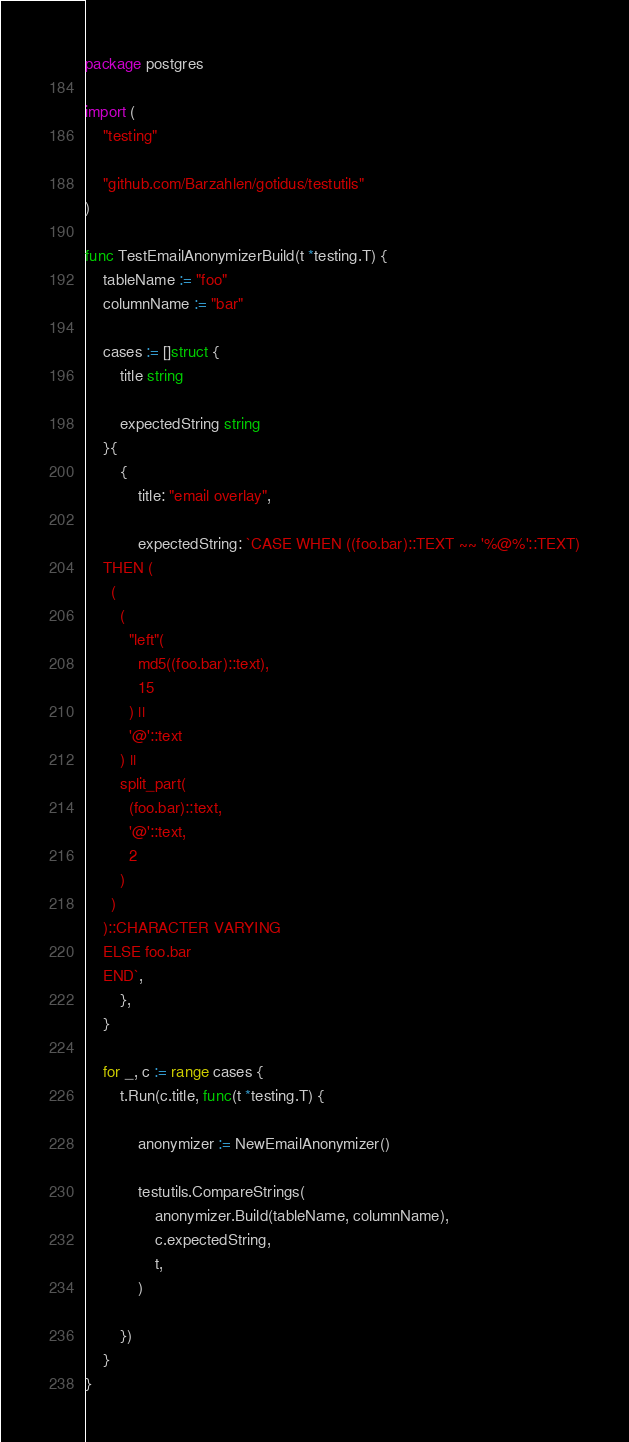Convert code to text. <code><loc_0><loc_0><loc_500><loc_500><_Go_>package postgres

import (
	"testing"

	"github.com/Barzahlen/gotidus/testutils"
)

func TestEmailAnonymizerBuild(t *testing.T) {
	tableName := "foo"
	columnName := "bar"

	cases := []struct {
		title string

		expectedString string
	}{
		{
			title: "email overlay",

			expectedString: `CASE WHEN ((foo.bar)::TEXT ~~ '%@%'::TEXT)
    THEN (
      (
        (
          "left"(
            md5((foo.bar)::text),
            15
          ) ||
          '@'::text
        ) ||
        split_part(
          (foo.bar)::text,
          '@'::text,
          2
        )
      )
    )::CHARACTER VARYING
    ELSE foo.bar
    END`,
		},
	}

	for _, c := range cases {
		t.Run(c.title, func(t *testing.T) {

			anonymizer := NewEmailAnonymizer()

			testutils.CompareStrings(
				anonymizer.Build(tableName, columnName),
				c.expectedString,
				t,
			)

		})
	}
}
</code> 